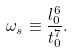Convert formula to latex. <formula><loc_0><loc_0><loc_500><loc_500>\omega _ { s } \equiv \frac { l _ { 0 } ^ { 6 } } { t _ { 0 } ^ { 7 } } .</formula> 